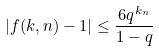Convert formula to latex. <formula><loc_0><loc_0><loc_500><loc_500>| f ( k , n ) - 1 | \leq \frac { 6 q ^ { k _ { n } } } { 1 - q }</formula> 